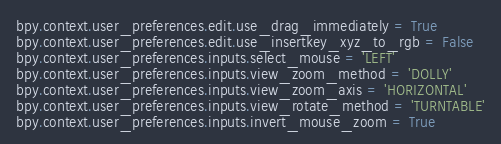<code> <loc_0><loc_0><loc_500><loc_500><_Python_>
bpy.context.user_preferences.edit.use_drag_immediately = True
bpy.context.user_preferences.edit.use_insertkey_xyz_to_rgb = False
bpy.context.user_preferences.inputs.select_mouse = 'LEFT'
bpy.context.user_preferences.inputs.view_zoom_method = 'DOLLY'
bpy.context.user_preferences.inputs.view_zoom_axis = 'HORIZONTAL'
bpy.context.user_preferences.inputs.view_rotate_method = 'TURNTABLE'
bpy.context.user_preferences.inputs.invert_mouse_zoom = True
</code> 